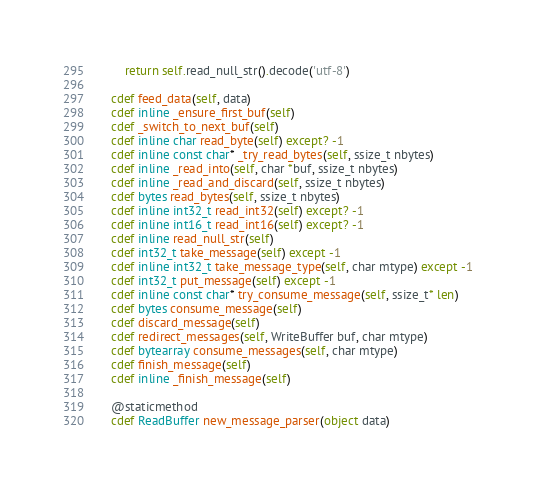<code> <loc_0><loc_0><loc_500><loc_500><_Cython_>        return self.read_null_str().decode('utf-8')

    cdef feed_data(self, data)
    cdef inline _ensure_first_buf(self)
    cdef _switch_to_next_buf(self)
    cdef inline char read_byte(self) except? -1
    cdef inline const char* _try_read_bytes(self, ssize_t nbytes)
    cdef inline _read_into(self, char *buf, ssize_t nbytes)
    cdef inline _read_and_discard(self, ssize_t nbytes)
    cdef bytes read_bytes(self, ssize_t nbytes)
    cdef inline int32_t read_int32(self) except? -1
    cdef inline int16_t read_int16(self) except? -1
    cdef inline read_null_str(self)
    cdef int32_t take_message(self) except -1
    cdef inline int32_t take_message_type(self, char mtype) except -1
    cdef int32_t put_message(self) except -1
    cdef inline const char* try_consume_message(self, ssize_t* len)
    cdef bytes consume_message(self)
    cdef discard_message(self)
    cdef redirect_messages(self, WriteBuffer buf, char mtype)
    cdef bytearray consume_messages(self, char mtype)
    cdef finish_message(self)
    cdef inline _finish_message(self)

    @staticmethod
    cdef ReadBuffer new_message_parser(object data)
</code> 